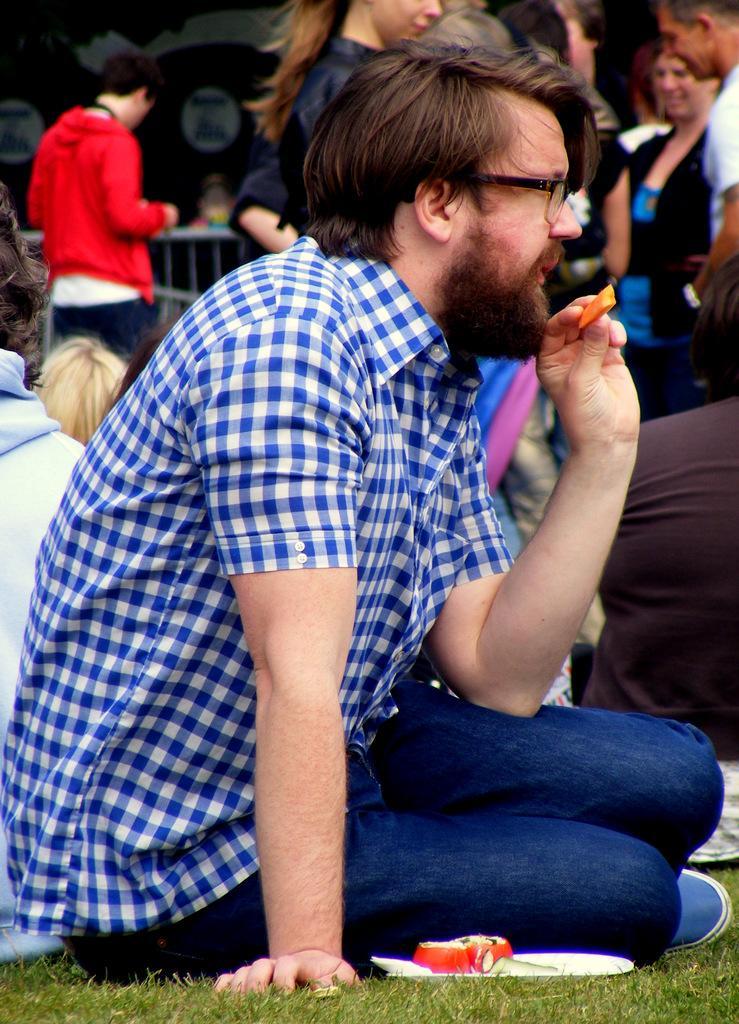Please provide a concise description of this image. In this picture we can see a man is sitting on the grass path and behind the man, there are groups of people sitting and some people are standing and on the path there is a plate with some food items. 